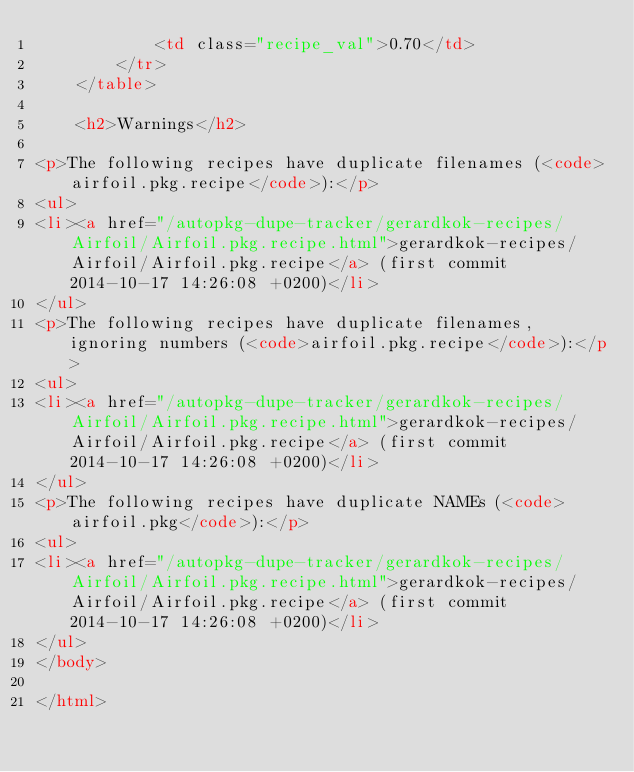Convert code to text. <code><loc_0><loc_0><loc_500><loc_500><_HTML_>            <td class="recipe_val">0.70</td>
        </tr>
    </table>

    <h2>Warnings</h2>
    
<p>The following recipes have duplicate filenames (<code>airfoil.pkg.recipe</code>):</p>
<ul>
<li><a href="/autopkg-dupe-tracker/gerardkok-recipes/Airfoil/Airfoil.pkg.recipe.html">gerardkok-recipes/Airfoil/Airfoil.pkg.recipe</a> (first commit 2014-10-17 14:26:08 +0200)</li>
</ul>
<p>The following recipes have duplicate filenames, ignoring numbers (<code>airfoil.pkg.recipe</code>):</p>
<ul>
<li><a href="/autopkg-dupe-tracker/gerardkok-recipes/Airfoil/Airfoil.pkg.recipe.html">gerardkok-recipes/Airfoil/Airfoil.pkg.recipe</a> (first commit 2014-10-17 14:26:08 +0200)</li>
</ul>
<p>The following recipes have duplicate NAMEs (<code>airfoil.pkg</code>):</p>
<ul>
<li><a href="/autopkg-dupe-tracker/gerardkok-recipes/Airfoil/Airfoil.pkg.recipe.html">gerardkok-recipes/Airfoil/Airfoil.pkg.recipe</a> (first commit 2014-10-17 14:26:08 +0200)</li>
</ul>
</body>

</html>
</code> 